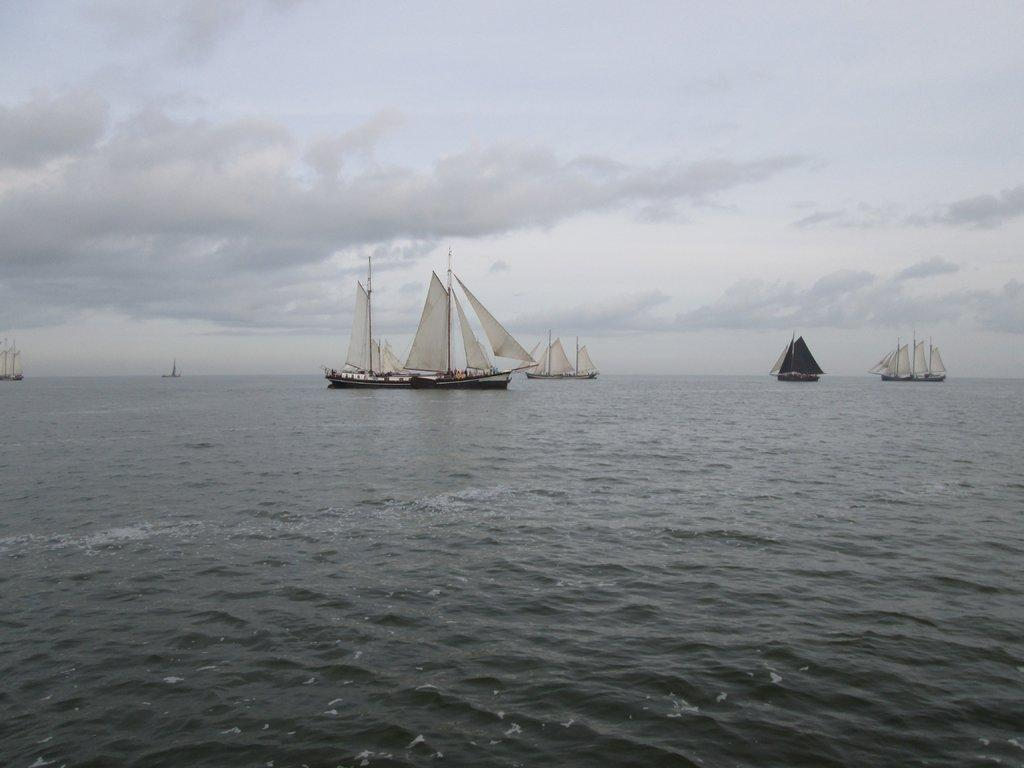What is the main subject of the image? The main subject of the image is water. What can be seen in the water? There are boats in the water. Where are the boats located in the image? The boats are in the middle of the image. What is visible in the background of the image? The sky is visible in the background of the image. How would you describe the sky in the image? The sky is cloudy. Can you see any icicles hanging from the boats in the image? There are no icicles visible in the image; it features water, boats, and a cloudy sky. 